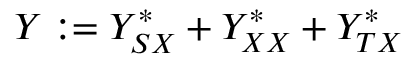<formula> <loc_0><loc_0><loc_500><loc_500>Y \colon = Y _ { S X } ^ { \ast } + Y _ { X X } ^ { \ast } + Y _ { T X } ^ { \ast }</formula> 